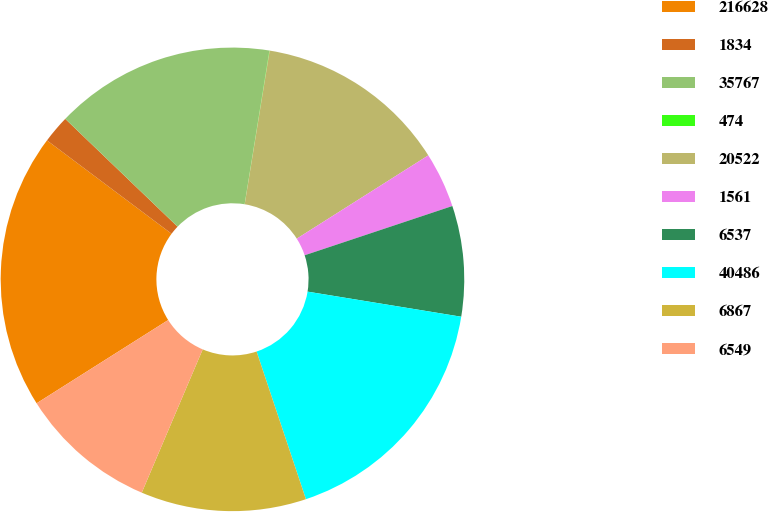Convert chart to OTSL. <chart><loc_0><loc_0><loc_500><loc_500><pie_chart><fcel>216628<fcel>1834<fcel>35767<fcel>474<fcel>20522<fcel>1561<fcel>6537<fcel>40486<fcel>6867<fcel>6549<nl><fcel>19.21%<fcel>1.94%<fcel>15.37%<fcel>0.02%<fcel>13.45%<fcel>3.86%<fcel>7.7%<fcel>17.29%<fcel>11.53%<fcel>9.62%<nl></chart> 